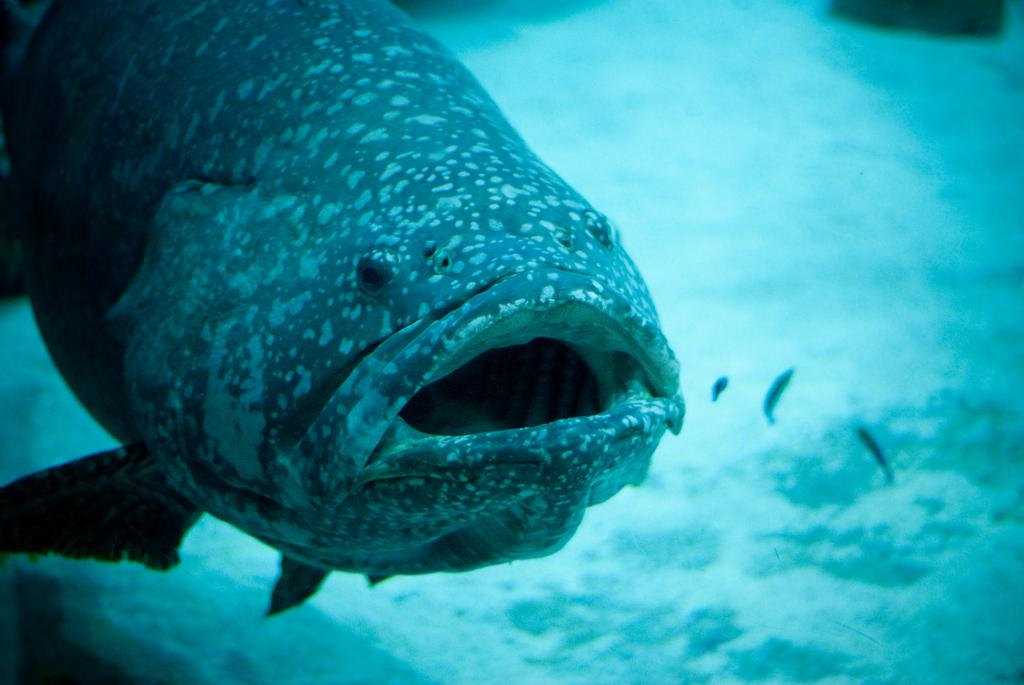What is the main subject of the image? There is a fish in the image. Where is the fish located? The fish is underwater. What color is the water in the image? The water in the image is blue. What type of nut is the fish holding in the image? There is no nut present in the image, as the fish is underwater and not holding any objects. 